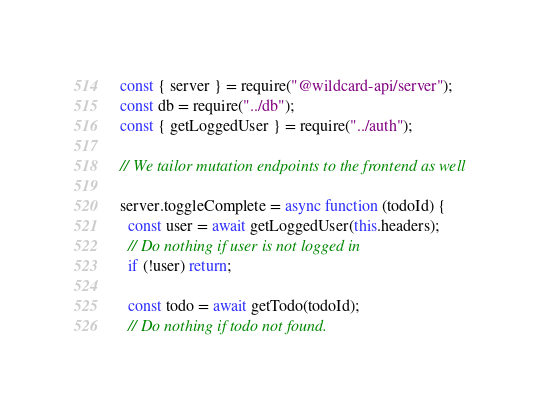<code> <loc_0><loc_0><loc_500><loc_500><_JavaScript_>const { server } = require("@wildcard-api/server");
const db = require("../db");
const { getLoggedUser } = require("../auth");

// We tailor mutation endpoints to the frontend as well

server.toggleComplete = async function (todoId) {
  const user = await getLoggedUser(this.headers);
  // Do nothing if user is not logged in
  if (!user) return;

  const todo = await getTodo(todoId);
  // Do nothing if todo not found.</code> 